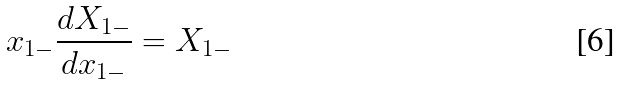<formula> <loc_0><loc_0><loc_500><loc_500>x _ { 1 - } \frac { d X _ { 1 - } } { d x _ { 1 - } } = X _ { 1 - }</formula> 